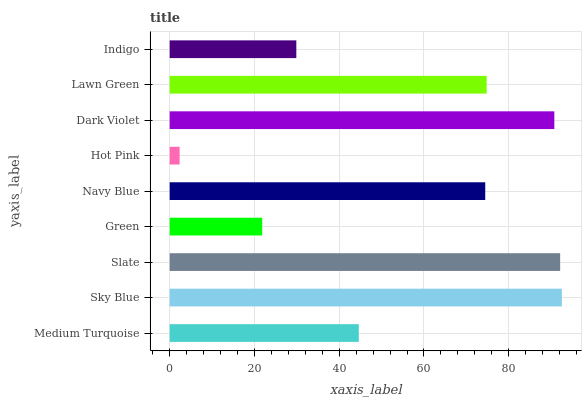Is Hot Pink the minimum?
Answer yes or no. Yes. Is Sky Blue the maximum?
Answer yes or no. Yes. Is Slate the minimum?
Answer yes or no. No. Is Slate the maximum?
Answer yes or no. No. Is Sky Blue greater than Slate?
Answer yes or no. Yes. Is Slate less than Sky Blue?
Answer yes or no. Yes. Is Slate greater than Sky Blue?
Answer yes or no. No. Is Sky Blue less than Slate?
Answer yes or no. No. Is Navy Blue the high median?
Answer yes or no. Yes. Is Navy Blue the low median?
Answer yes or no. Yes. Is Medium Turquoise the high median?
Answer yes or no. No. Is Sky Blue the low median?
Answer yes or no. No. 